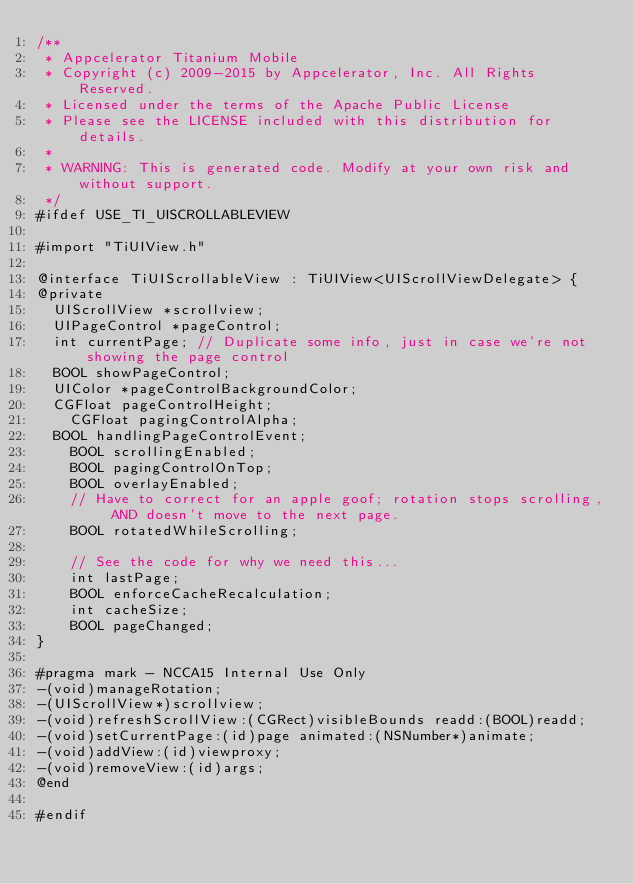<code> <loc_0><loc_0><loc_500><loc_500><_C_>/**
 * Appcelerator Titanium Mobile
 * Copyright (c) 2009-2015 by Appcelerator, Inc. All Rights Reserved.
 * Licensed under the terms of the Apache Public License
 * Please see the LICENSE included with this distribution for details.
 * 
 * WARNING: This is generated code. Modify at your own risk and without support.
 */
#ifdef USE_TI_UISCROLLABLEVIEW

#import "TiUIView.h"

@interface TiUIScrollableView : TiUIView<UIScrollViewDelegate> {
@private
	UIScrollView *scrollview;
	UIPageControl *pageControl;
	int currentPage; // Duplicate some info, just in case we're not showing the page control
	BOOL showPageControl;
	UIColor *pageControlBackgroundColor;
	CGFloat pageControlHeight;
    CGFloat pagingControlAlpha;
	BOOL handlingPageControlEvent;
    BOOL scrollingEnabled;
    BOOL pagingControlOnTop;
    BOOL overlayEnabled;
    // Have to correct for an apple goof; rotation stops scrolling, AND doesn't move to the next page.
    BOOL rotatedWhileScrolling;

    // See the code for why we need this...
    int lastPage;
    BOOL enforceCacheRecalculation;
    int cacheSize;
    BOOL pageChanged;
}

#pragma mark - NCCA15 Internal Use Only
-(void)manageRotation;
-(UIScrollView*)scrollview;
-(void)refreshScrollView:(CGRect)visibleBounds readd:(BOOL)readd;
-(void)setCurrentPage:(id)page animated:(NSNumber*)animate;
-(void)addView:(id)viewproxy;
-(void)removeView:(id)args;
@end

#endif</code> 